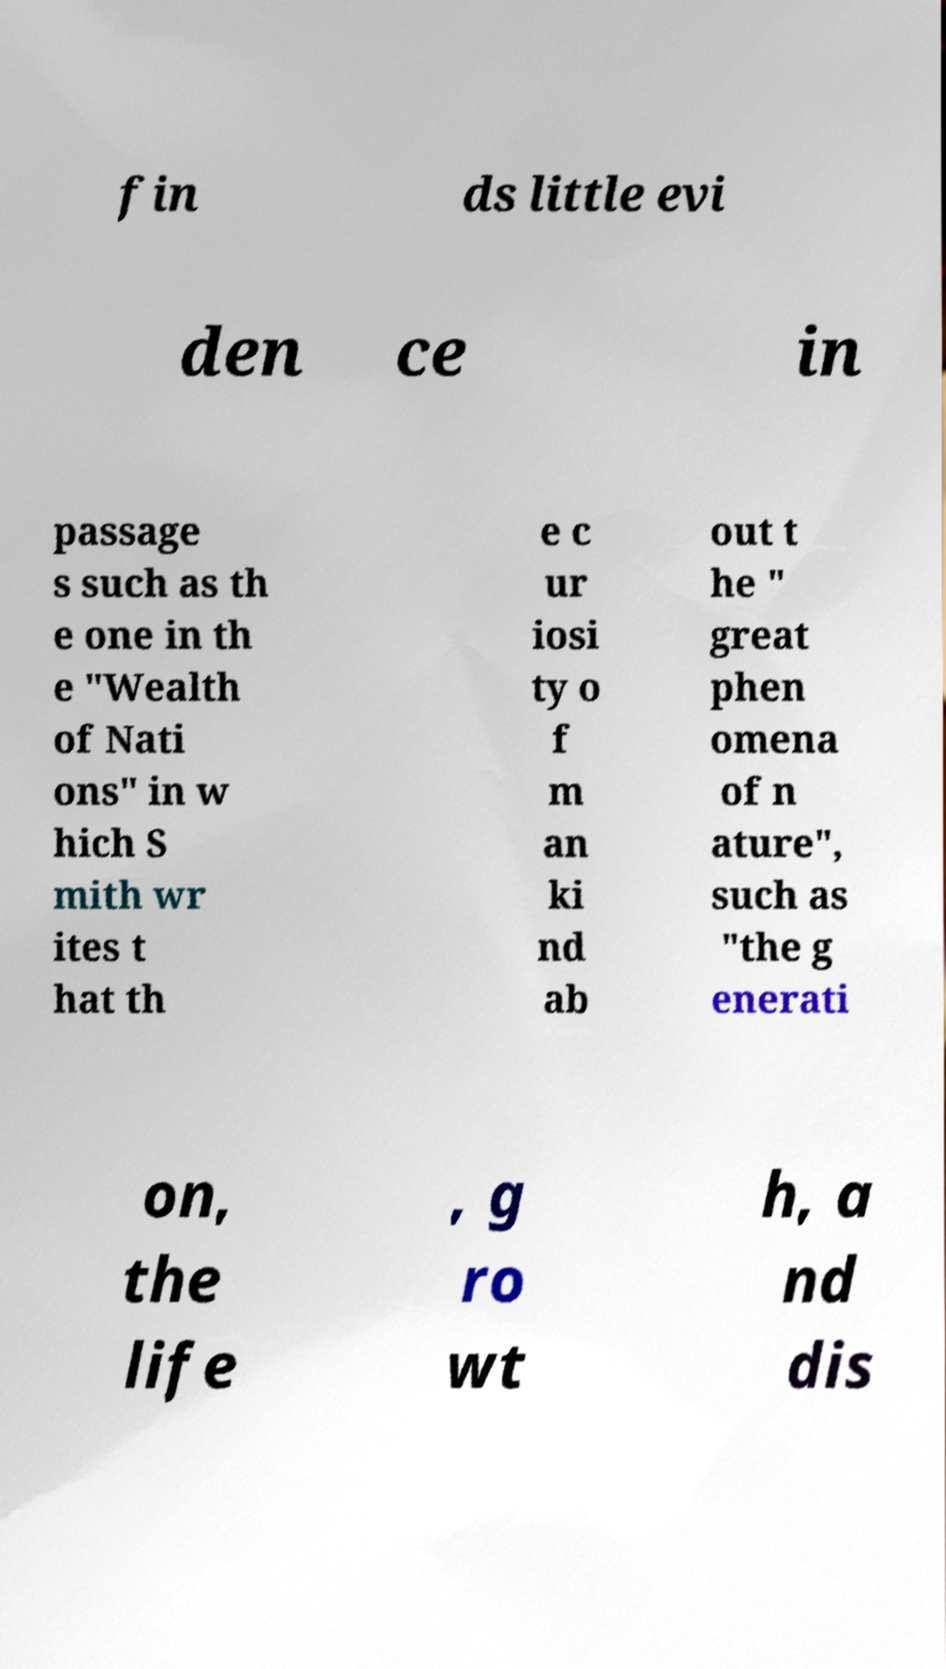Can you accurately transcribe the text from the provided image for me? fin ds little evi den ce in passage s such as th e one in th e "Wealth of Nati ons" in w hich S mith wr ites t hat th e c ur iosi ty o f m an ki nd ab out t he " great phen omena of n ature", such as "the g enerati on, the life , g ro wt h, a nd dis 